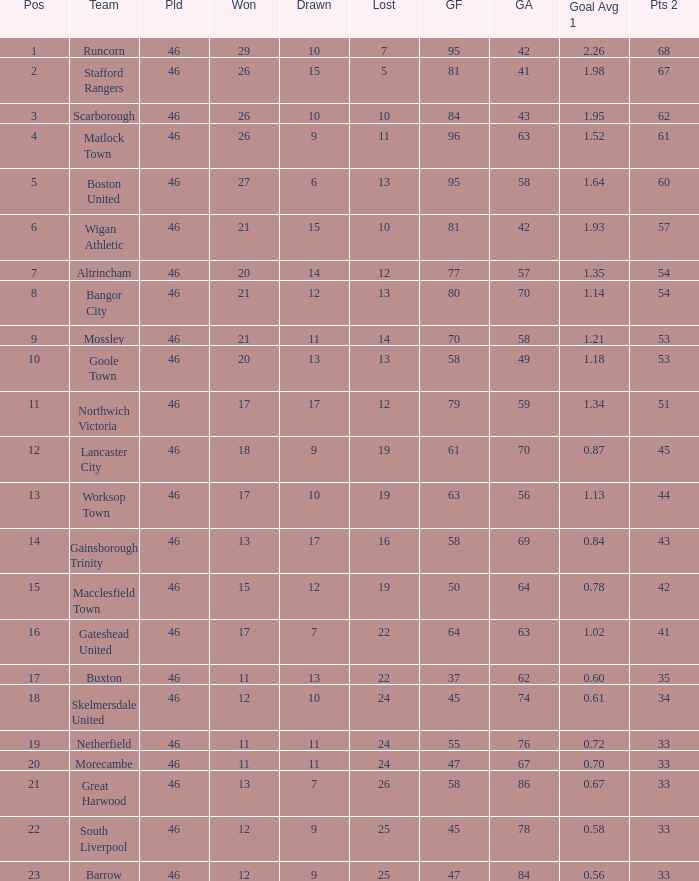List all losses with average goals of 1.21. 14.0. Can you give me this table as a dict? {'header': ['Pos', 'Team', 'Pld', 'Won', 'Drawn', 'Lost', 'GF', 'GA', 'Goal Avg 1', 'Pts 2'], 'rows': [['1', 'Runcorn', '46', '29', '10', '7', '95', '42', '2.26', '68'], ['2', 'Stafford Rangers', '46', '26', '15', '5', '81', '41', '1.98', '67'], ['3', 'Scarborough', '46', '26', '10', '10', '84', '43', '1.95', '62'], ['4', 'Matlock Town', '46', '26', '9', '11', '96', '63', '1.52', '61'], ['5', 'Boston United', '46', '27', '6', '13', '95', '58', '1.64', '60'], ['6', 'Wigan Athletic', '46', '21', '15', '10', '81', '42', '1.93', '57'], ['7', 'Altrincham', '46', '20', '14', '12', '77', '57', '1.35', '54'], ['8', 'Bangor City', '46', '21', '12', '13', '80', '70', '1.14', '54'], ['9', 'Mossley', '46', '21', '11', '14', '70', '58', '1.21', '53'], ['10', 'Goole Town', '46', '20', '13', '13', '58', '49', '1.18', '53'], ['11', 'Northwich Victoria', '46', '17', '17', '12', '79', '59', '1.34', '51'], ['12', 'Lancaster City', '46', '18', '9', '19', '61', '70', '0.87', '45'], ['13', 'Worksop Town', '46', '17', '10', '19', '63', '56', '1.13', '44'], ['14', 'Gainsborough Trinity', '46', '13', '17', '16', '58', '69', '0.84', '43'], ['15', 'Macclesfield Town', '46', '15', '12', '19', '50', '64', '0.78', '42'], ['16', 'Gateshead United', '46', '17', '7', '22', '64', '63', '1.02', '41'], ['17', 'Buxton', '46', '11', '13', '22', '37', '62', '0.60', '35'], ['18', 'Skelmersdale United', '46', '12', '10', '24', '45', '74', '0.61', '34'], ['19', 'Netherfield', '46', '11', '11', '24', '55', '76', '0.72', '33'], ['20', 'Morecambe', '46', '11', '11', '24', '47', '67', '0.70', '33'], ['21', 'Great Harwood', '46', '13', '7', '26', '58', '86', '0.67', '33'], ['22', 'South Liverpool', '46', '12', '9', '25', '45', '78', '0.58', '33'], ['23', 'Barrow', '46', '12', '9', '25', '47', '84', '0.56', '33']]} 